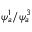Convert formula to latex. <formula><loc_0><loc_0><loc_500><loc_500>\psi _ { a } ^ { 1 } / \psi _ { a } ^ { 3 }</formula> 